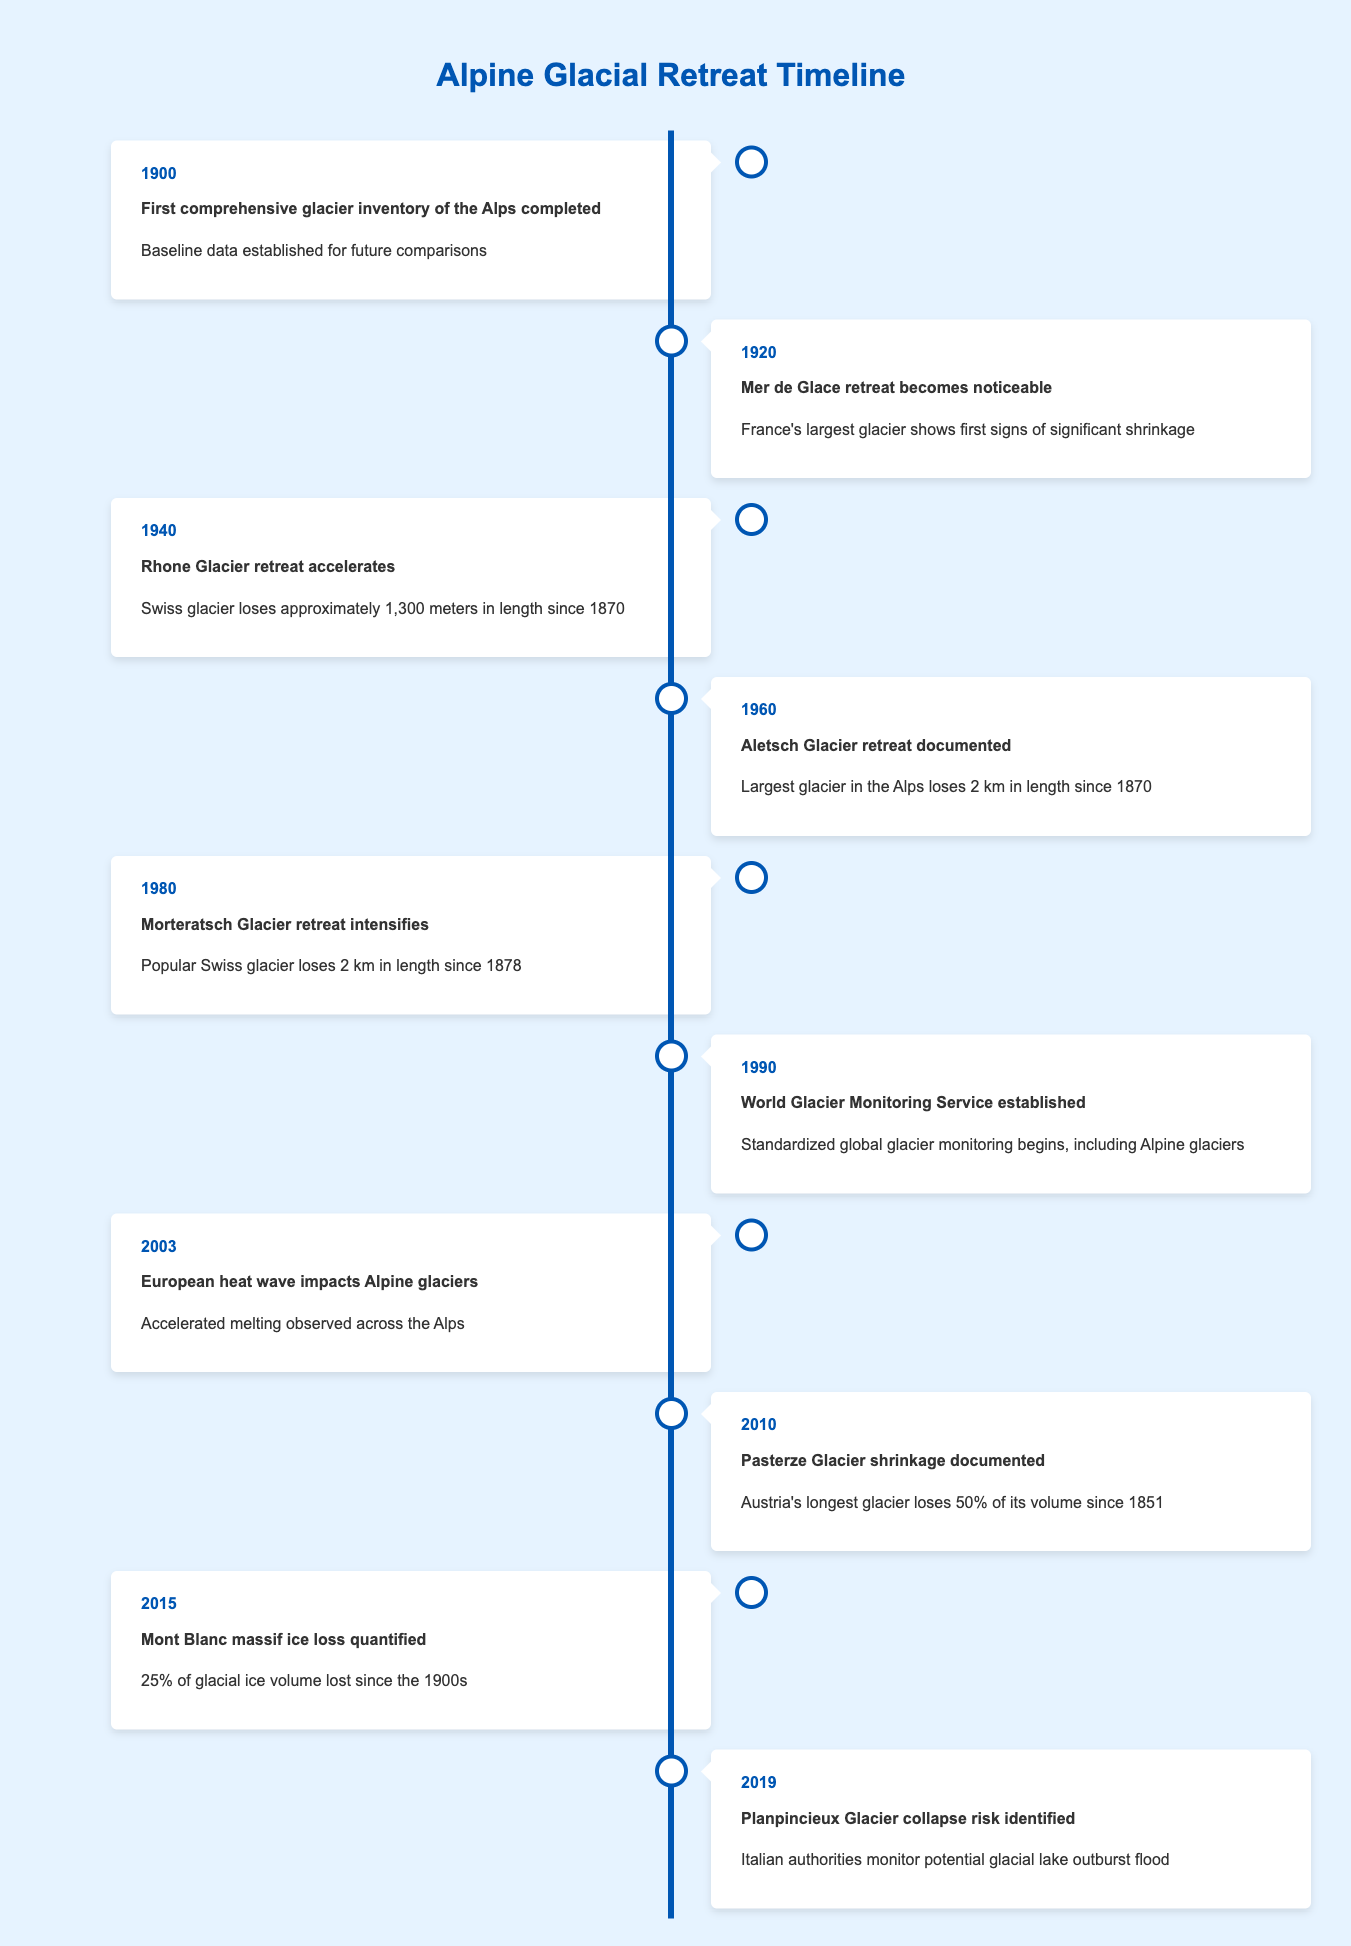What year did the first comprehensive glacier inventory of the Alps get completed? The table indicates that the first comprehensive glacier inventory of the Alps was completed in the year 1900.
Answer: 1900 Which glacier showed noticeable retreat in 1920? According to the table, the Mer de Glace, which is France's largest glacier, showed noticeable retreat in 1920.
Answer: Mer de Glace How much did the Rhone Glacier lose in length by 1940? The table states that by 1940, the Rhone Glacier had lost approximately 1,300 meters in length since 1870, which is directly indicated in that row.
Answer: Approximately 1,300 meters What is the total length lost by Aletsch Glacier and Morteratsch Glacier combined since 1870 and 1878 respectively? Aletsch Glacier lost 2 km since 1870 as mentioned in 1960, and Morteratsch Glacier lost 2 km since 1878 as mentioned in 1980. Therefore, the total length lost by both glaciers is 2 km + 2 km = 4 km.
Answer: 4 km Did the Pasterze Glacier lose less than 50% of its volume since 1851? The table indicates that Pasterze Glacier lost 50% of its volume since 1851. Therefore, the statement is false as it did not lose less than that percentage.
Answer: No In which year was the European heat wave reported, impacting Alpine glaciers? The event of the European heat wave affecting Alpine glaciers is recorded in 2003.
Answer: 2003 What percentage of glacial ice volume was lost from Mont Blanc massif since the 1900s? The information in the table states that 25% of the glacial ice volume was lost from Mont Blanc massif since the 1900s, which is listed in the event for 2015.
Answer: 25% Which glacier was noted for risks of collapse in 2019? According to the table, the Planpincieux Glacier was noted for risks of collapse in 2019, stated in the corresponding row.
Answer: Planpincieux Glacier What year marks the establishment of the World Glacier Monitoring Service? The establishment of the World Glacier Monitoring Service is recorded in 1990, as stated in its event row.
Answer: 1990 What is the average volume loss percentage among the losing glaciers mentioned in the timeline? By reviewing the information, we find that Pasterze Glacier lost 50% and Mont Blanc massif lost 25%, while Aletsch Glacier lost 2 km (not a percentage directly). That's two values—50% and 25%. The average is (50 + 25)/2 = 37.5%.
Answer: 37.5% 